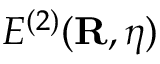Convert formula to latex. <formula><loc_0><loc_0><loc_500><loc_500>E ^ { ( 2 ) } ( { R } , { \boldsymbol \eta } )</formula> 